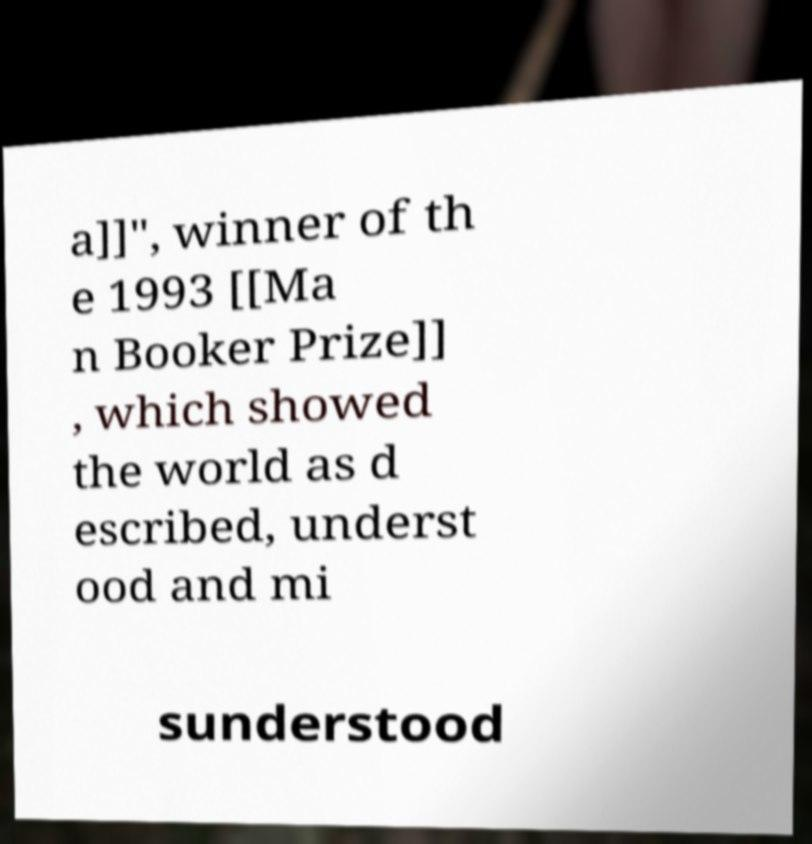Please read and relay the text visible in this image. What does it say? a]]", winner of th e 1993 [[Ma n Booker Prize]] , which showed the world as d escribed, underst ood and mi sunderstood 